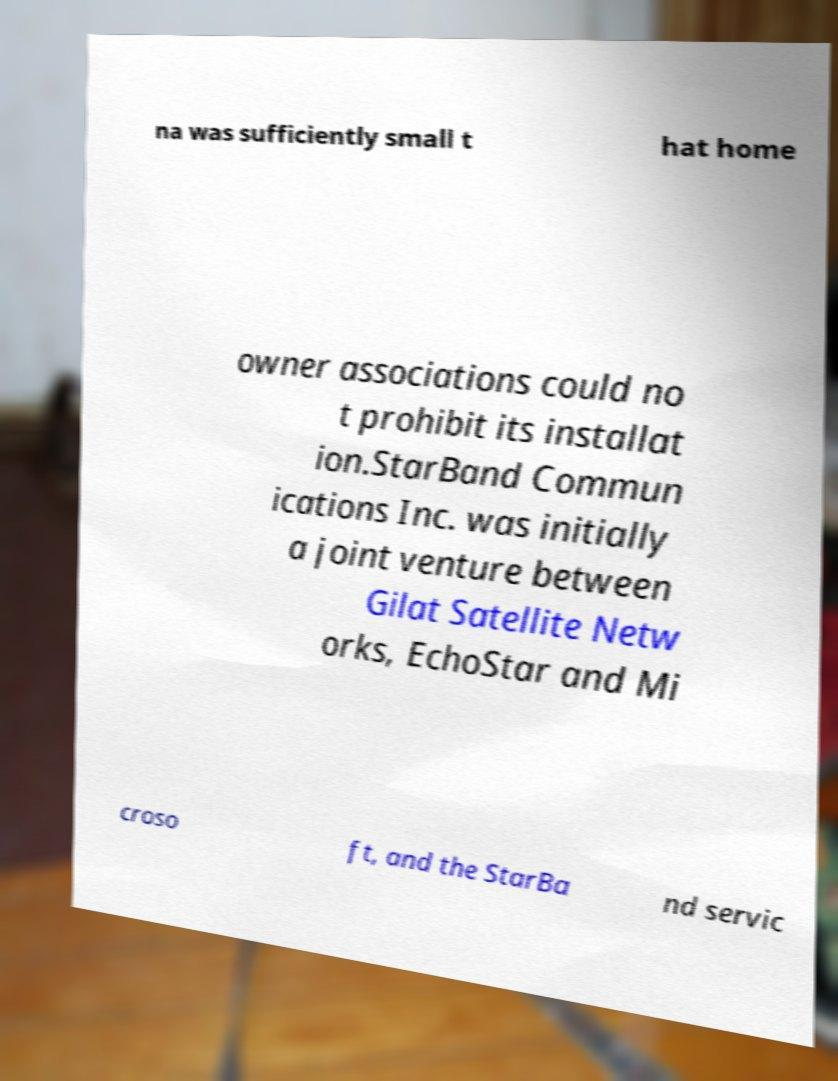Please identify and transcribe the text found in this image. na was sufficiently small t hat home owner associations could no t prohibit its installat ion.StarBand Commun ications Inc. was initially a joint venture between Gilat Satellite Netw orks, EchoStar and Mi croso ft, and the StarBa nd servic 